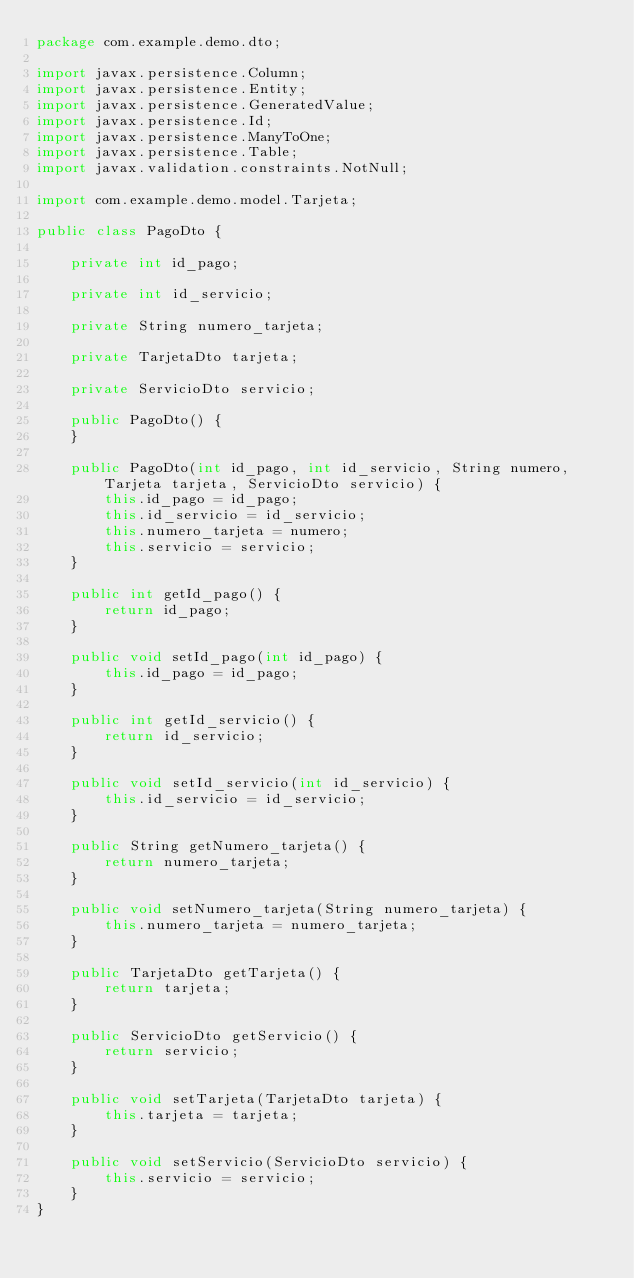<code> <loc_0><loc_0><loc_500><loc_500><_Java_>package com.example.demo.dto;

import javax.persistence.Column;
import javax.persistence.Entity;
import javax.persistence.GeneratedValue;
import javax.persistence.Id;
import javax.persistence.ManyToOne;
import javax.persistence.Table;
import javax.validation.constraints.NotNull;

import com.example.demo.model.Tarjeta;

public class PagoDto {

    private int id_pago;

    private int id_servicio;

    private String numero_tarjeta;

    private TarjetaDto tarjeta;

    private ServicioDto servicio;

    public PagoDto() {
    }

    public PagoDto(int id_pago, int id_servicio, String numero, Tarjeta tarjeta, ServicioDto servicio) {
        this.id_pago = id_pago;
        this.id_servicio = id_servicio;
        this.numero_tarjeta = numero;
        this.servicio = servicio;
    }

    public int getId_pago() {
        return id_pago;
    }

    public void setId_pago(int id_pago) {
        this.id_pago = id_pago;
    }

    public int getId_servicio() {
        return id_servicio;
    }

    public void setId_servicio(int id_servicio) {
        this.id_servicio = id_servicio;
    }

    public String getNumero_tarjeta() {
        return numero_tarjeta;
    }

    public void setNumero_tarjeta(String numero_tarjeta) {
        this.numero_tarjeta = numero_tarjeta;
    }

    public TarjetaDto getTarjeta() {
        return tarjeta;
    }

    public ServicioDto getServicio() {
        return servicio;
    }

    public void setTarjeta(TarjetaDto tarjeta) {
        this.tarjeta = tarjeta;
    }

    public void setServicio(ServicioDto servicio) {
        this.servicio = servicio;
    }
}
</code> 